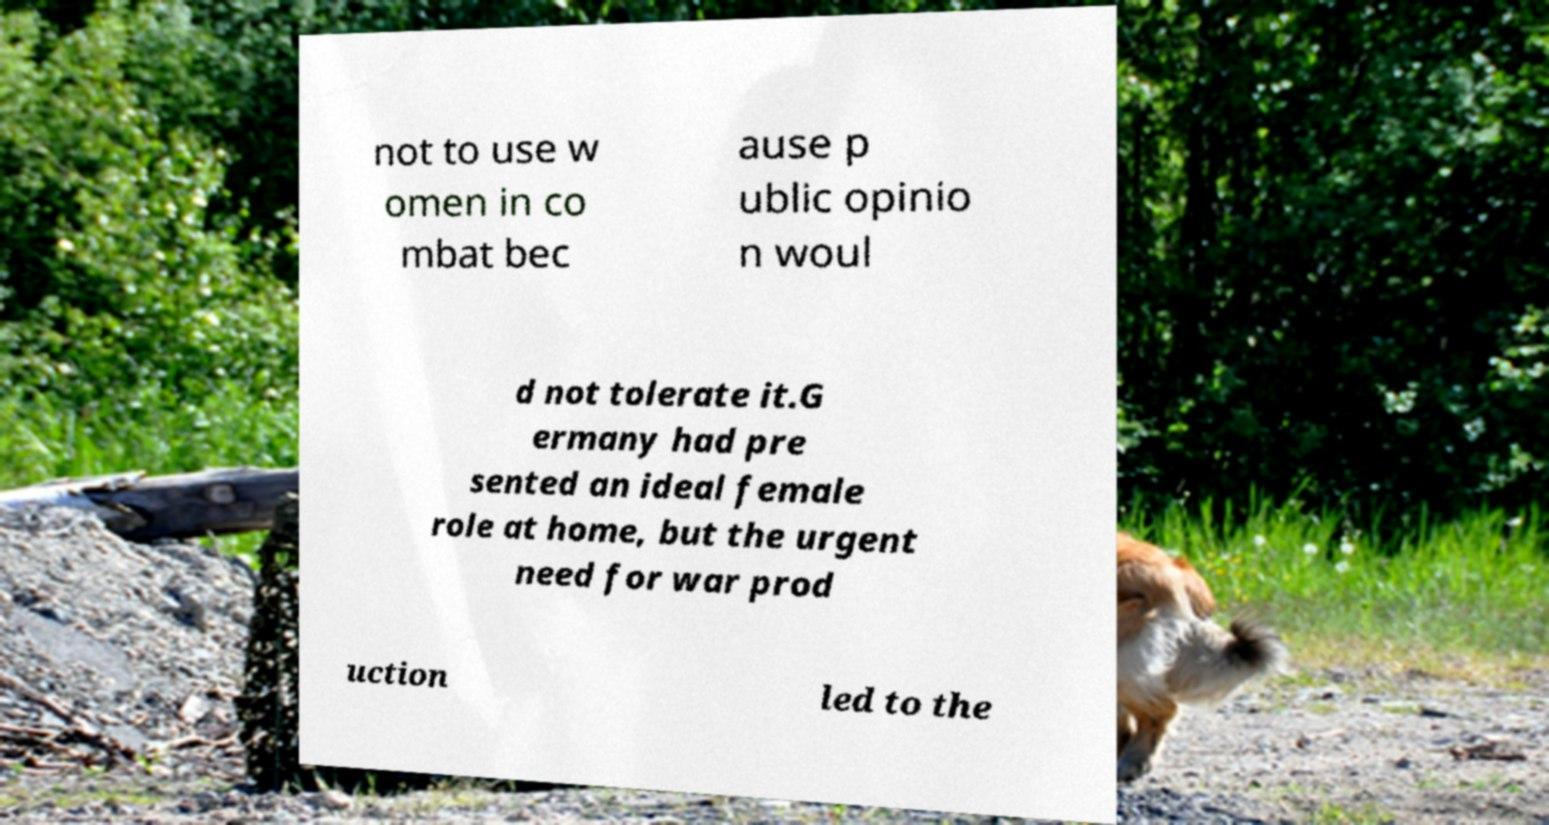Can you accurately transcribe the text from the provided image for me? not to use w omen in co mbat bec ause p ublic opinio n woul d not tolerate it.G ermany had pre sented an ideal female role at home, but the urgent need for war prod uction led to the 